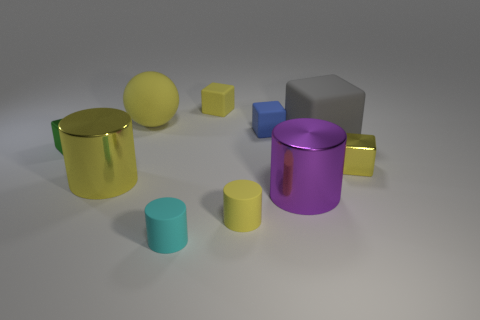Is there anything else that is the same material as the tiny blue cube?
Give a very brief answer. Yes. There is another cylinder that is the same size as the cyan cylinder; what color is it?
Your answer should be compact. Yellow. Is the material of the large yellow object that is behind the small blue object the same as the green object?
Offer a terse response. No. There is a metal object that is on the left side of the big yellow thing in front of the gray matte block; are there any large gray objects that are in front of it?
Offer a very short reply. No. There is a small metal thing that is on the right side of the big yellow metal thing; does it have the same shape as the green shiny thing?
Your answer should be very brief. Yes. What is the shape of the object that is in front of the small yellow matte thing that is in front of the green shiny thing?
Your answer should be compact. Cylinder. What is the size of the yellow rubber object that is in front of the tiny yellow thing that is to the right of the matte block to the right of the purple metallic thing?
Your answer should be very brief. Small. There is another matte thing that is the same shape as the small cyan matte thing; what color is it?
Keep it short and to the point. Yellow. Is the size of the yellow matte block the same as the blue rubber block?
Offer a very short reply. Yes. What is the small yellow block behind the small blue block made of?
Your response must be concise. Rubber. 